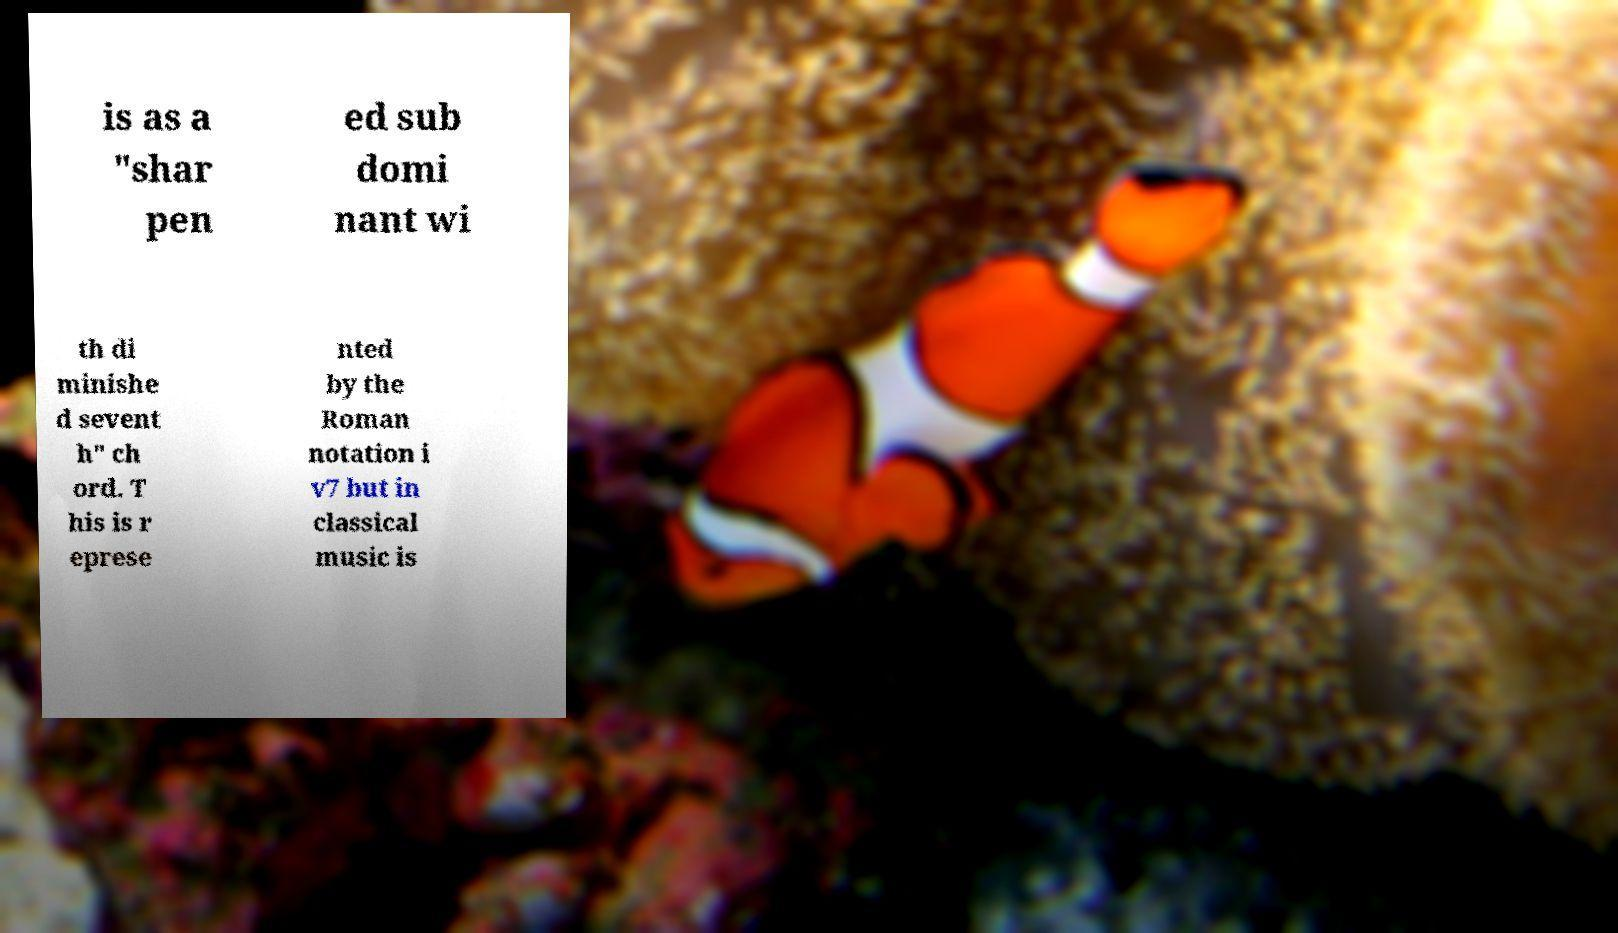Please read and relay the text visible in this image. What does it say? is as a "shar pen ed sub domi nant wi th di minishe d sevent h" ch ord. T his is r eprese nted by the Roman notation i v7 but in classical music is 